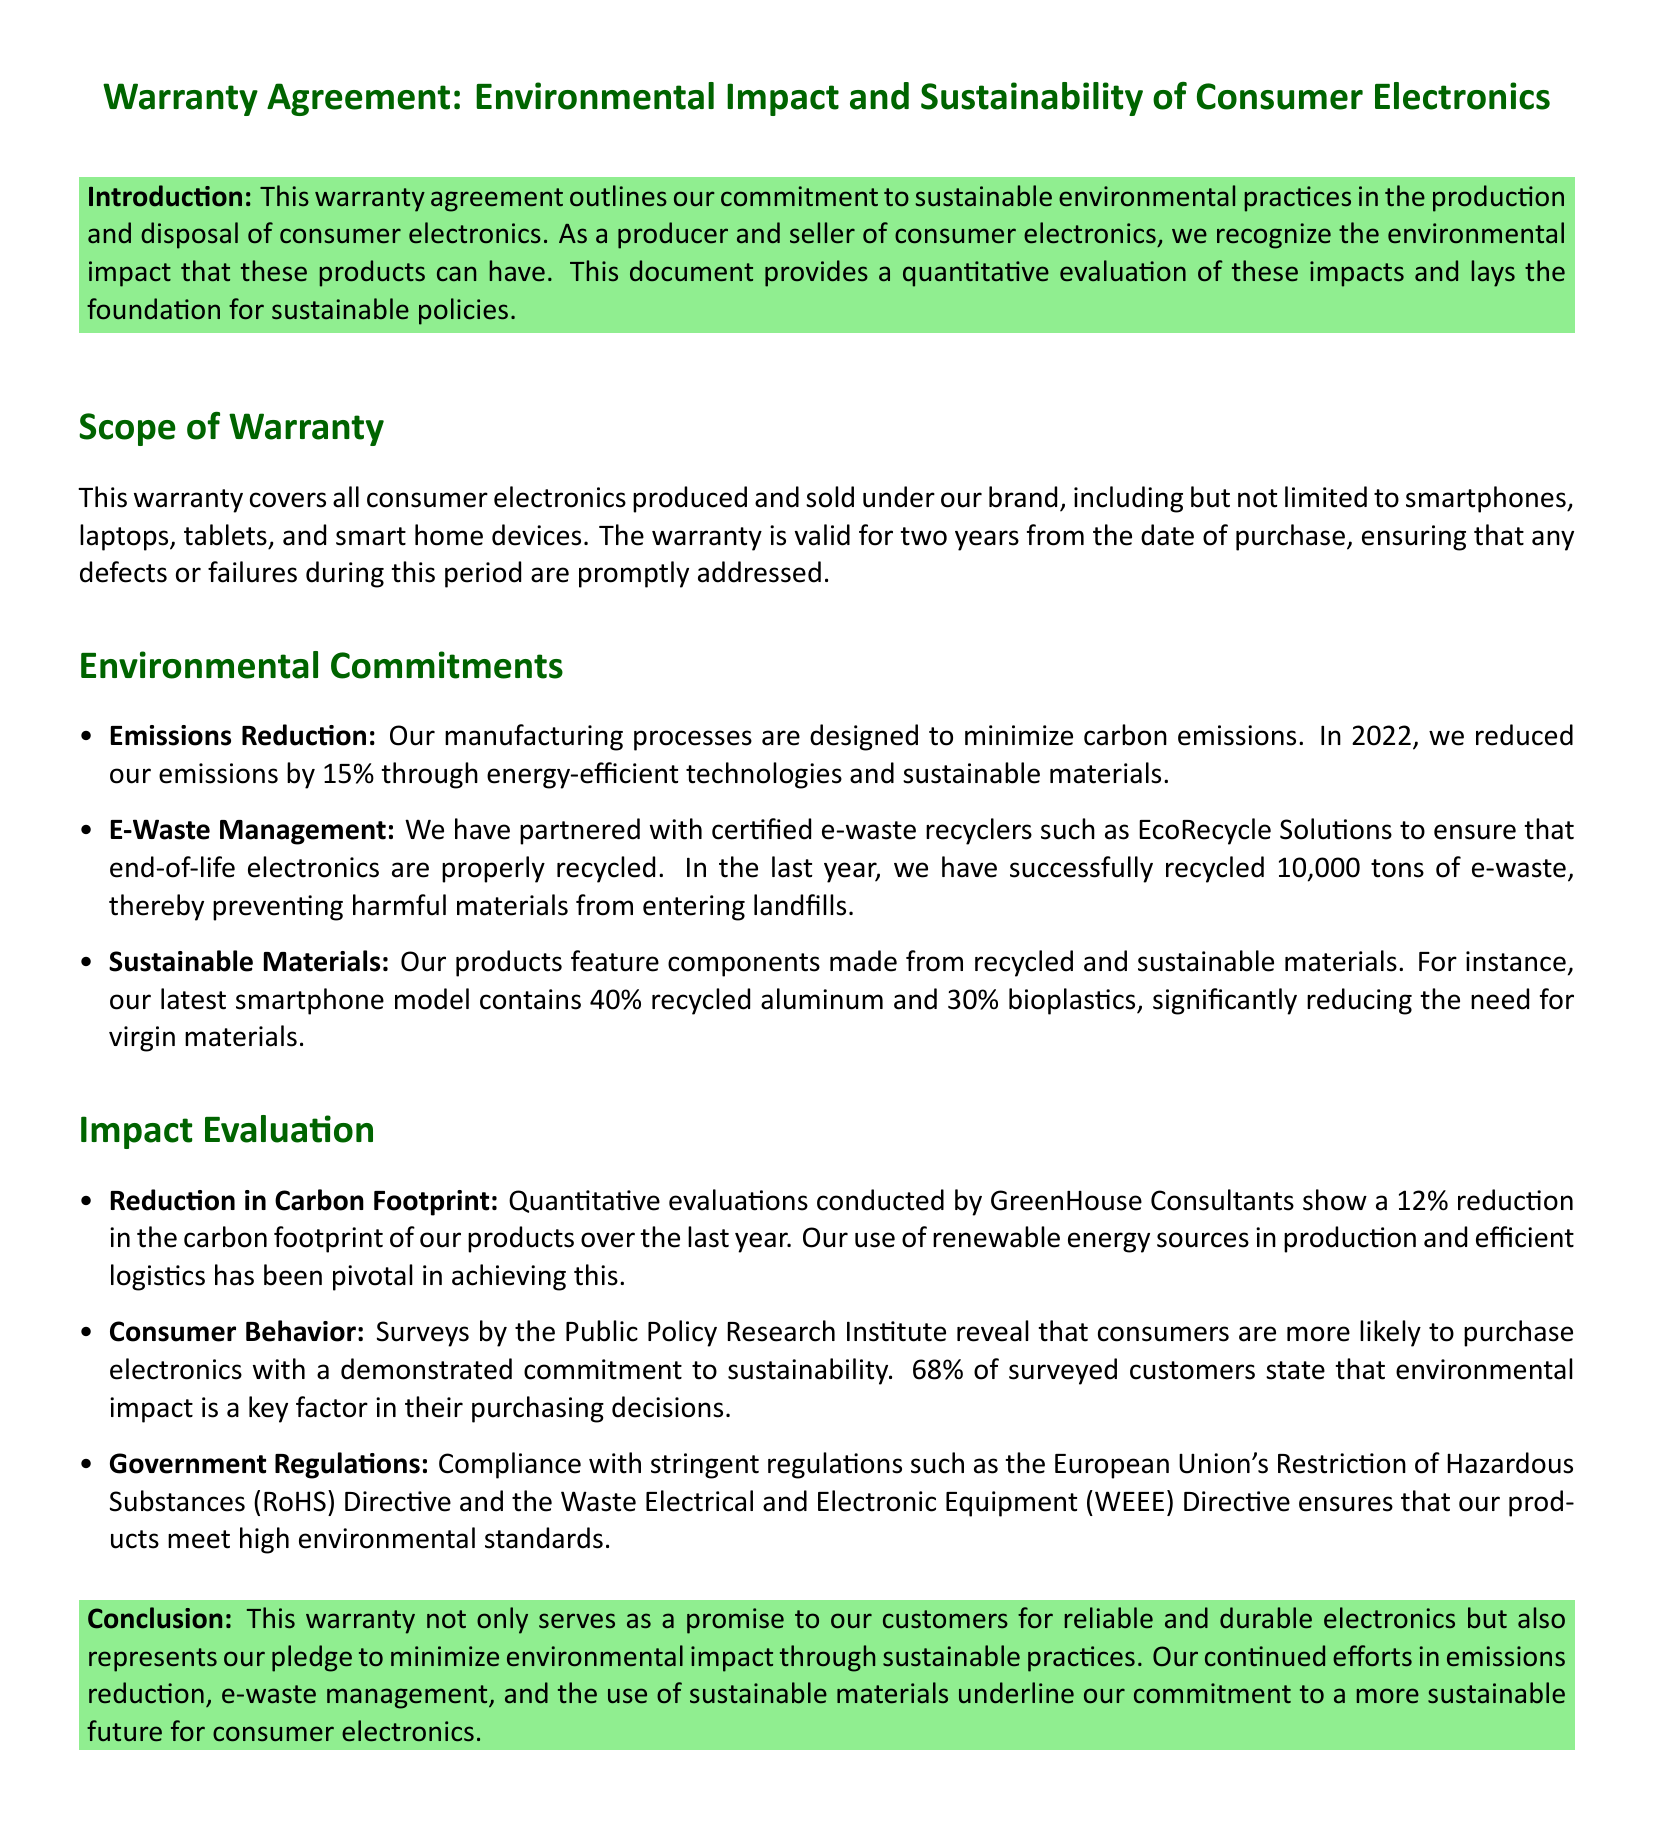What is the duration of the warranty? The warranty is valid for two years from the date of purchase.
Answer: two years What percentage of recycled aluminum is used in the latest smartphone model? The document states that the latest smartphone model contains 40% recycled aluminum.
Answer: 40% Who has the company partnered with for e-waste recycling? The document mentions EcoRecycle Solutions as a certified e-waste recycler partner.
Answer: EcoRecycle Solutions What reduction percentage in carbon emissions was achieved in 2022? The document indicates a 15% reduction in carbon emissions through sustainable practices.
Answer: 15% Which organization's surveys indicated consumer preferences regarding sustainability? The Public Policy Research Institute conducted the surveys revealing consumer preferences.
Answer: Public Policy Research Institute What percentage of surveyed customers consider environmental impact in their purchasing decisions? According to the surveys, 68% of surveyed customers regard environmental impact as a key factor.
Answer: 68% What is the title of this warranty agreement? The document is titled "Warranty Agreement: Environmental Impact and Sustainability of Consumer Electronics."
Answer: Warranty Agreement: Environmental Impact and Sustainability of Consumer Electronics What significant environmental regulations does the company comply with? The company complies with the EU's RoHS and WEEE directives as mentioned in the document.
Answer: RoHS and WEEE What was the amount of e-waste successfully recycled last year? The warranty agreement states that 10,000 tons of e-waste have been recycled.
Answer: 10,000 tons 